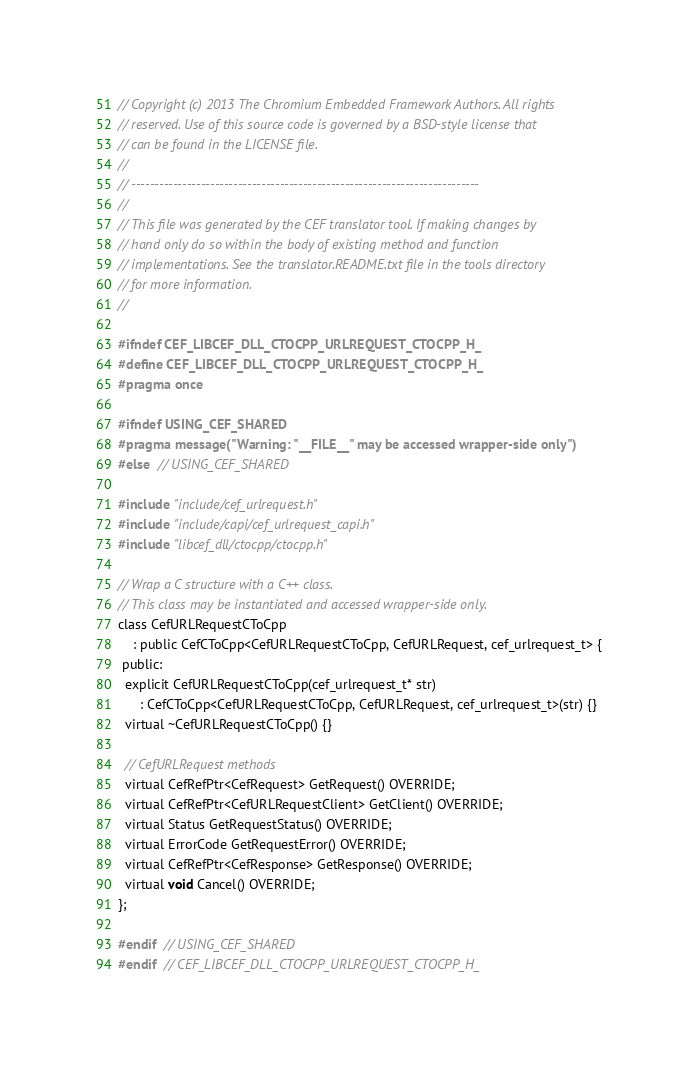<code> <loc_0><loc_0><loc_500><loc_500><_C_>// Copyright (c) 2013 The Chromium Embedded Framework Authors. All rights
// reserved. Use of this source code is governed by a BSD-style license that
// can be found in the LICENSE file.
//
// ---------------------------------------------------------------------------
//
// This file was generated by the CEF translator tool. If making changes by
// hand only do so within the body of existing method and function
// implementations. See the translator.README.txt file in the tools directory
// for more information.
//

#ifndef CEF_LIBCEF_DLL_CTOCPP_URLREQUEST_CTOCPP_H_
#define CEF_LIBCEF_DLL_CTOCPP_URLREQUEST_CTOCPP_H_
#pragma once

#ifndef USING_CEF_SHARED
#pragma message("Warning: "__FILE__" may be accessed wrapper-side only")
#else  // USING_CEF_SHARED

#include "include/cef_urlrequest.h"
#include "include/capi/cef_urlrequest_capi.h"
#include "libcef_dll/ctocpp/ctocpp.h"

// Wrap a C structure with a C++ class.
// This class may be instantiated and accessed wrapper-side only.
class CefURLRequestCToCpp
    : public CefCToCpp<CefURLRequestCToCpp, CefURLRequest, cef_urlrequest_t> {
 public:
  explicit CefURLRequestCToCpp(cef_urlrequest_t* str)
      : CefCToCpp<CefURLRequestCToCpp, CefURLRequest, cef_urlrequest_t>(str) {}
  virtual ~CefURLRequestCToCpp() {}

  // CefURLRequest methods
  virtual CefRefPtr<CefRequest> GetRequest() OVERRIDE;
  virtual CefRefPtr<CefURLRequestClient> GetClient() OVERRIDE;
  virtual Status GetRequestStatus() OVERRIDE;
  virtual ErrorCode GetRequestError() OVERRIDE;
  virtual CefRefPtr<CefResponse> GetResponse() OVERRIDE;
  virtual void Cancel() OVERRIDE;
};

#endif  // USING_CEF_SHARED
#endif  // CEF_LIBCEF_DLL_CTOCPP_URLREQUEST_CTOCPP_H_

</code> 